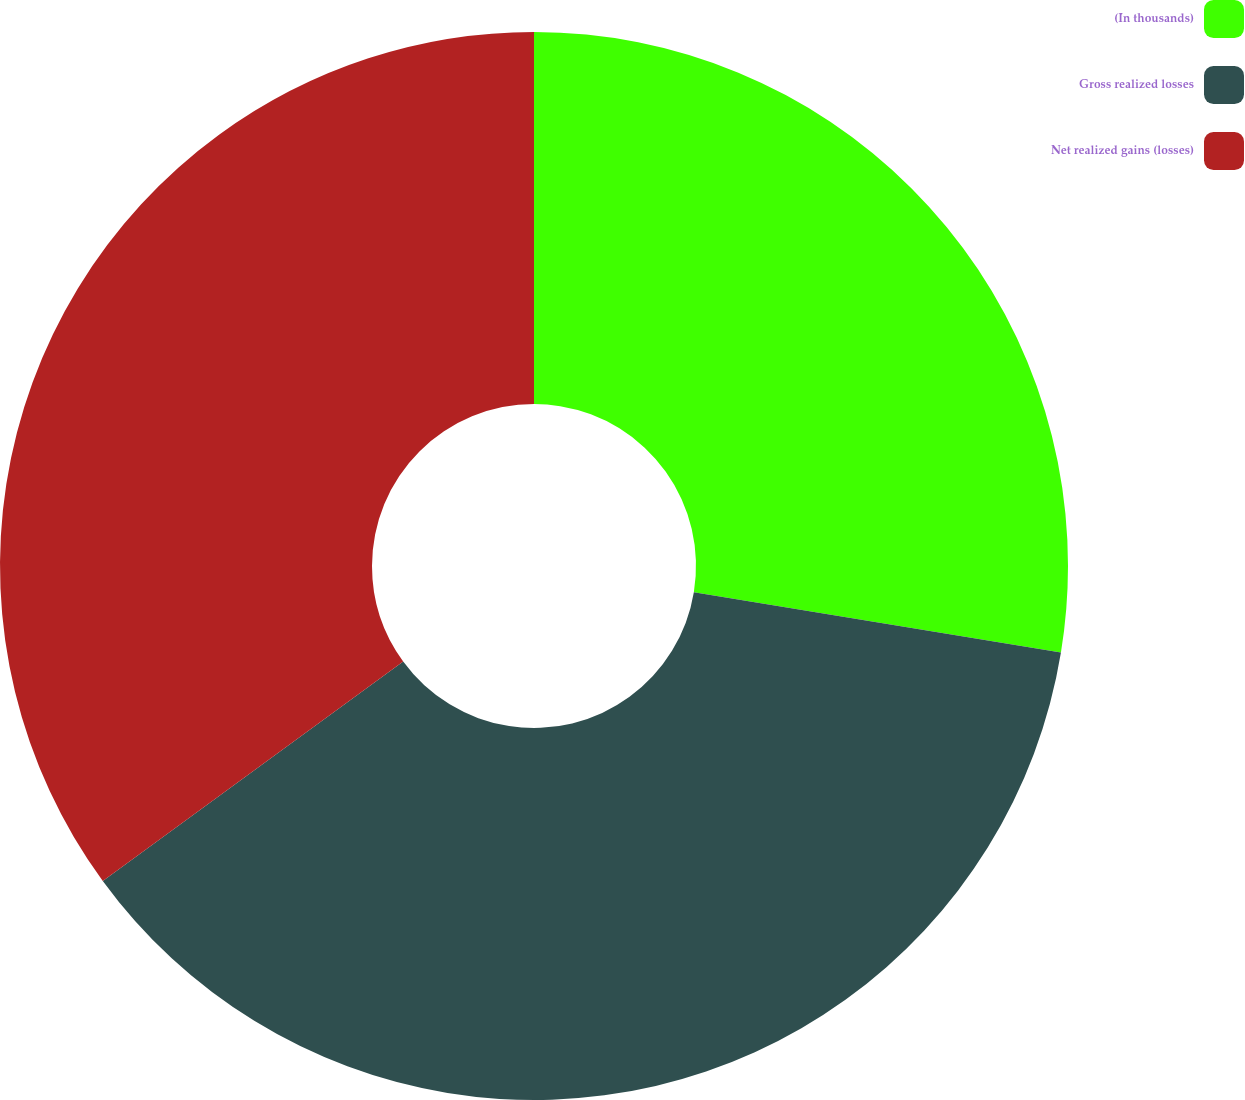Convert chart to OTSL. <chart><loc_0><loc_0><loc_500><loc_500><pie_chart><fcel>(In thousands)<fcel>Gross realized losses<fcel>Net realized gains (losses)<nl><fcel>27.59%<fcel>37.37%<fcel>35.04%<nl></chart> 